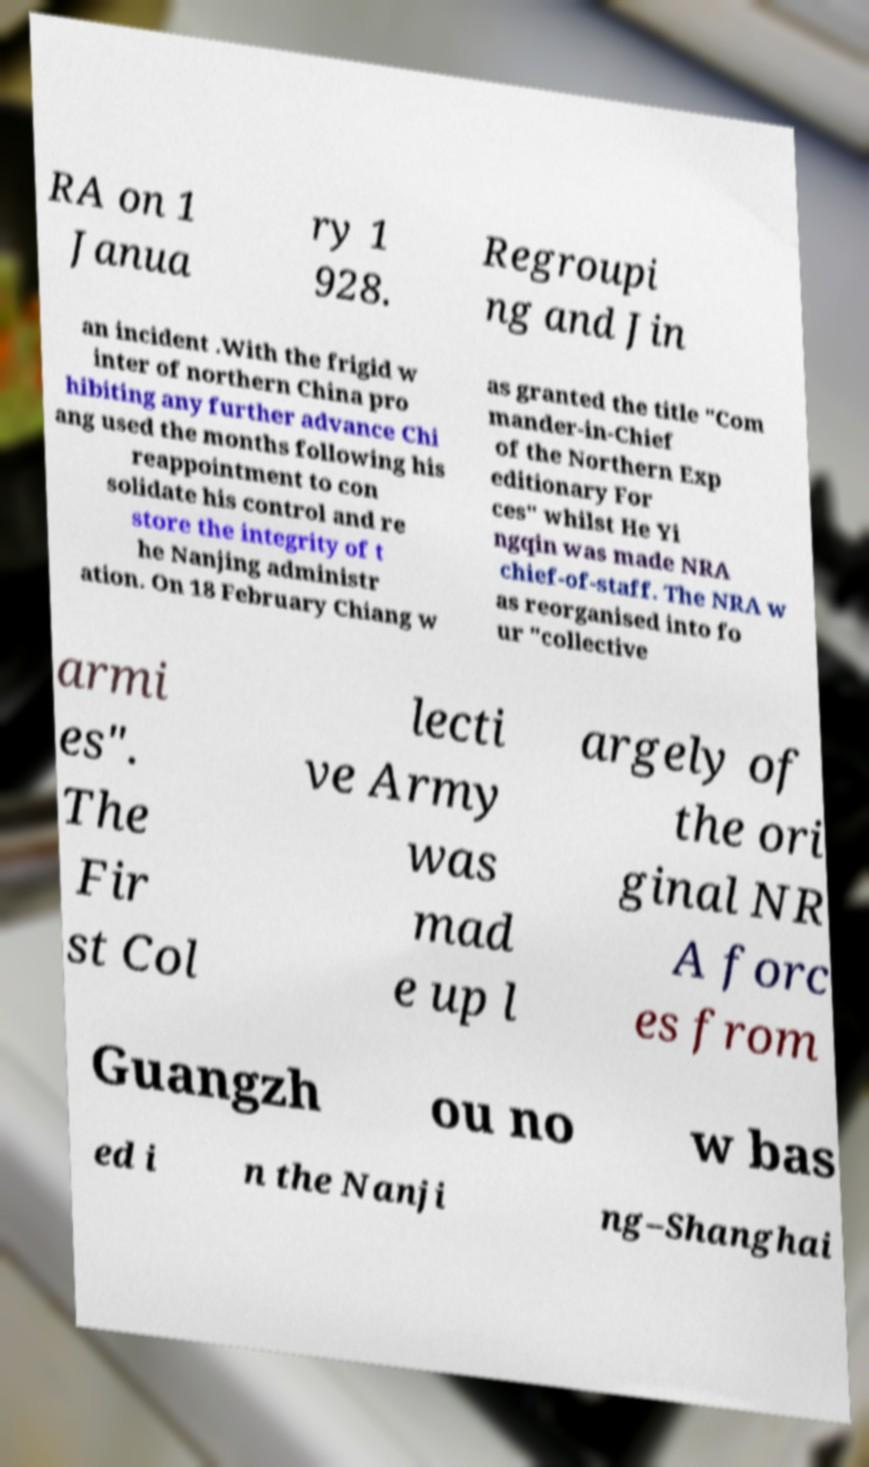Can you read and provide the text displayed in the image?This photo seems to have some interesting text. Can you extract and type it out for me? RA on 1 Janua ry 1 928. Regroupi ng and Jin an incident .With the frigid w inter of northern China pro hibiting any further advance Chi ang used the months following his reappointment to con solidate his control and re store the integrity of t he Nanjing administr ation. On 18 February Chiang w as granted the title "Com mander-in-Chief of the Northern Exp editionary For ces" whilst He Yi ngqin was made NRA chief-of-staff. The NRA w as reorganised into fo ur "collective armi es". The Fir st Col lecti ve Army was mad e up l argely of the ori ginal NR A forc es from Guangzh ou no w bas ed i n the Nanji ng–Shanghai 